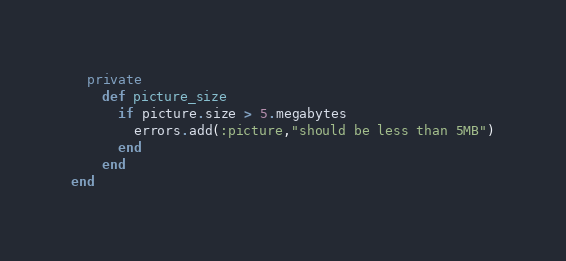Convert code to text. <code><loc_0><loc_0><loc_500><loc_500><_Ruby_>  private
    def picture_size
      if picture.size > 5.megabytes
        errors.add(:picture,"should be less than 5MB")
      end
    end
end
</code> 